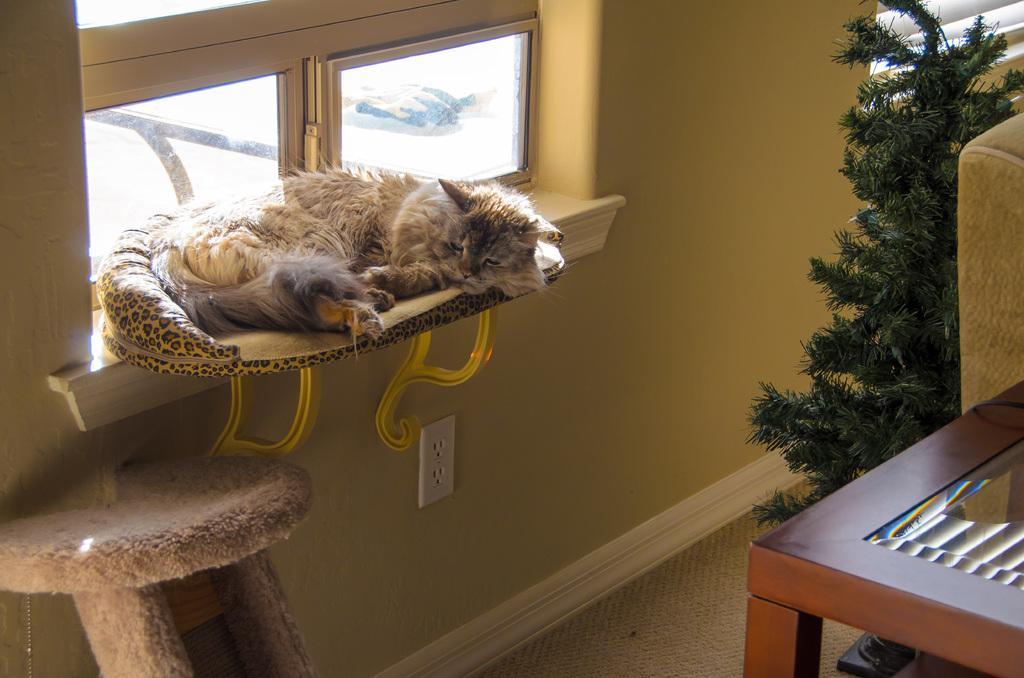Please provide a concise description of this image. In the image we can see there is a cat who is sleeping on the cat bed. 